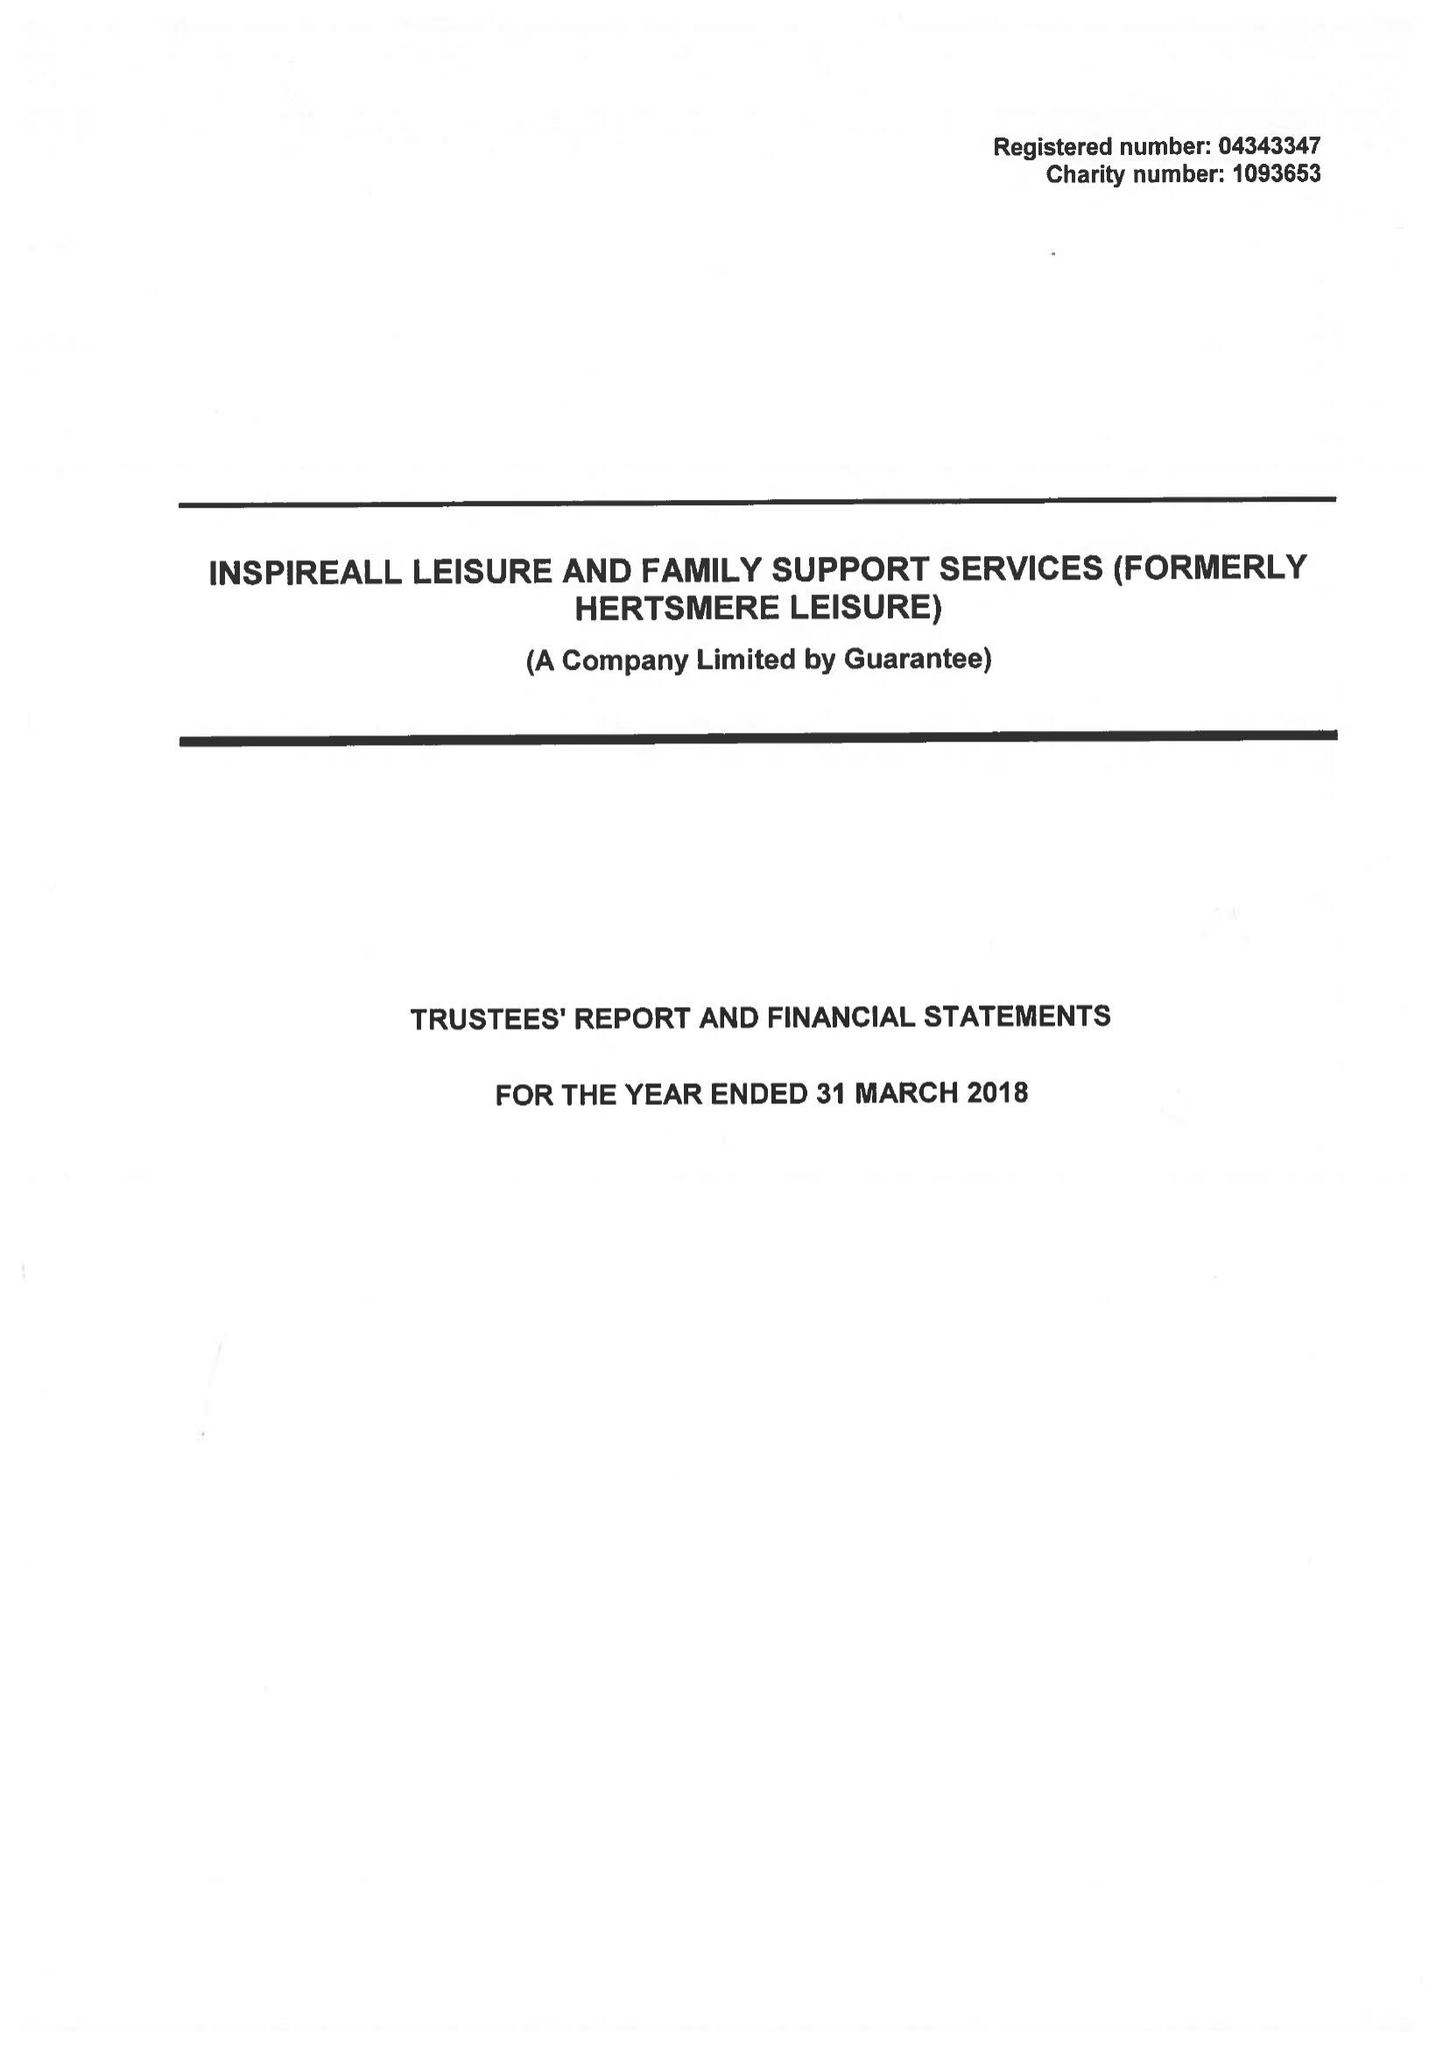What is the value for the income_annually_in_british_pounds?
Answer the question using a single word or phrase. 19379644.00 